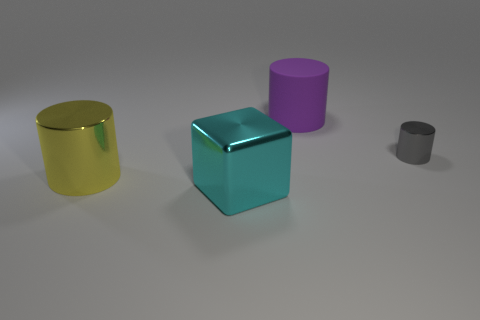There is a object that is both to the left of the tiny gray thing and behind the yellow thing; what material is it?
Provide a succinct answer. Rubber. There is a metallic object that is on the right side of the purple rubber cylinder; is its size the same as the cube?
Your response must be concise. No. What is the shape of the cyan shiny object?
Your answer should be very brief. Cube. What number of other big objects have the same shape as the cyan object?
Your response must be concise. 0. What number of big things are right of the big yellow metal cylinder and in front of the big purple object?
Provide a short and direct response. 1. What is the color of the small metal thing?
Offer a terse response. Gray. Are there any cyan things made of the same material as the cube?
Offer a terse response. No. Are there any big cylinders right of the cylinder that is left of the big purple rubber cylinder that is left of the tiny metal cylinder?
Ensure brevity in your answer.  Yes. There is a shiny cube; are there any large yellow metal things in front of it?
Make the answer very short. No. What number of big things are red rubber things or cylinders?
Provide a succinct answer. 2. 